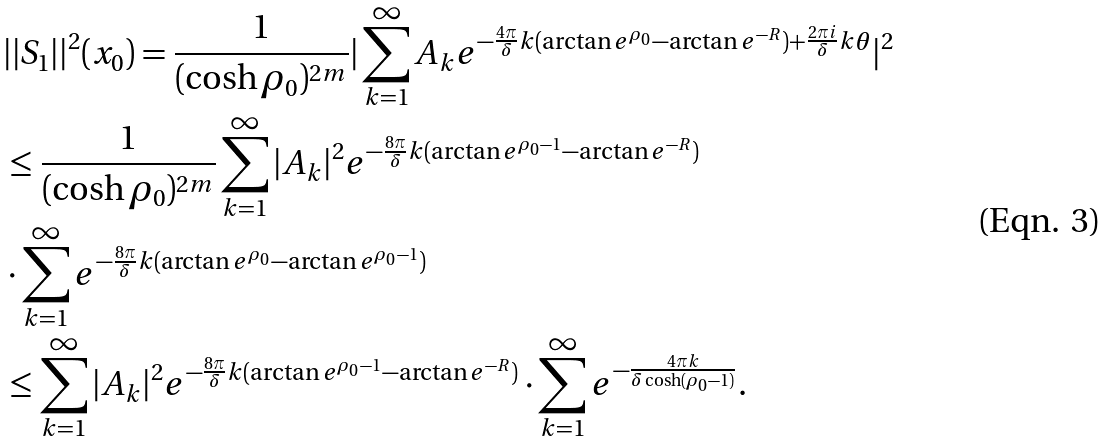<formula> <loc_0><loc_0><loc_500><loc_500>& | | S _ { 1 } | | ^ { 2 } ( x _ { 0 } ) = \frac { 1 } { ( \cosh \rho _ { 0 } ) ^ { 2 m } } | \sum _ { k = 1 } ^ { \infty } A _ { k } e ^ { - \frac { 4 \pi } { \delta } k ( \arctan e ^ { \rho _ { 0 } } - \arctan e ^ { - R } ) + \frac { 2 \pi i } { \delta } k \theta } | ^ { 2 } \\ & \leq \frac { 1 } { ( \cosh \rho _ { 0 } ) ^ { 2 m } } \sum _ { k = 1 } ^ { \infty } | A _ { k } | ^ { 2 } e ^ { - \frac { 8 \pi } { \delta } k ( \arctan e ^ { \rho _ { 0 } - 1 } - \arctan e ^ { - R } ) } \\ \quad & \cdot \sum _ { k = 1 } ^ { \infty } e ^ { - \frac { 8 \pi } { \delta } k ( \arctan e ^ { \rho _ { 0 } } - \arctan e ^ { \rho _ { 0 } - 1 } ) } \\ & \leq \sum _ { k = 1 } ^ { \infty } | A _ { k } | ^ { 2 } e ^ { - \frac { 8 \pi } { \delta } k ( \arctan e ^ { \rho _ { 0 } - 1 } - \arctan e ^ { - R } ) } \cdot \sum _ { k = 1 } ^ { \infty } e ^ { - \frac { 4 \pi k } { \delta \cosh ( \rho _ { 0 } - 1 ) } } .</formula> 